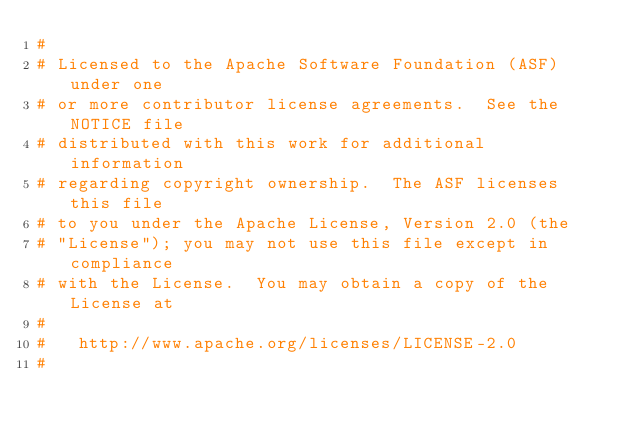Convert code to text. <code><loc_0><loc_0><loc_500><loc_500><_Python_>#
# Licensed to the Apache Software Foundation (ASF) under one
# or more contributor license agreements.  See the NOTICE file
# distributed with this work for additional information
# regarding copyright ownership.  The ASF licenses this file
# to you under the Apache License, Version 2.0 (the
# "License"); you may not use this file except in compliance
# with the License.  You may obtain a copy of the License at
#
#   http://www.apache.org/licenses/LICENSE-2.0
#</code> 